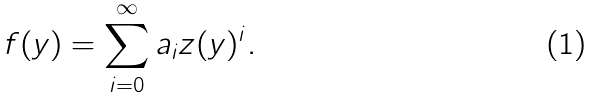<formula> <loc_0><loc_0><loc_500><loc_500>f ( y ) = \sum _ { i = 0 } ^ { \infty } a _ { i } z ( y ) ^ { i } .</formula> 